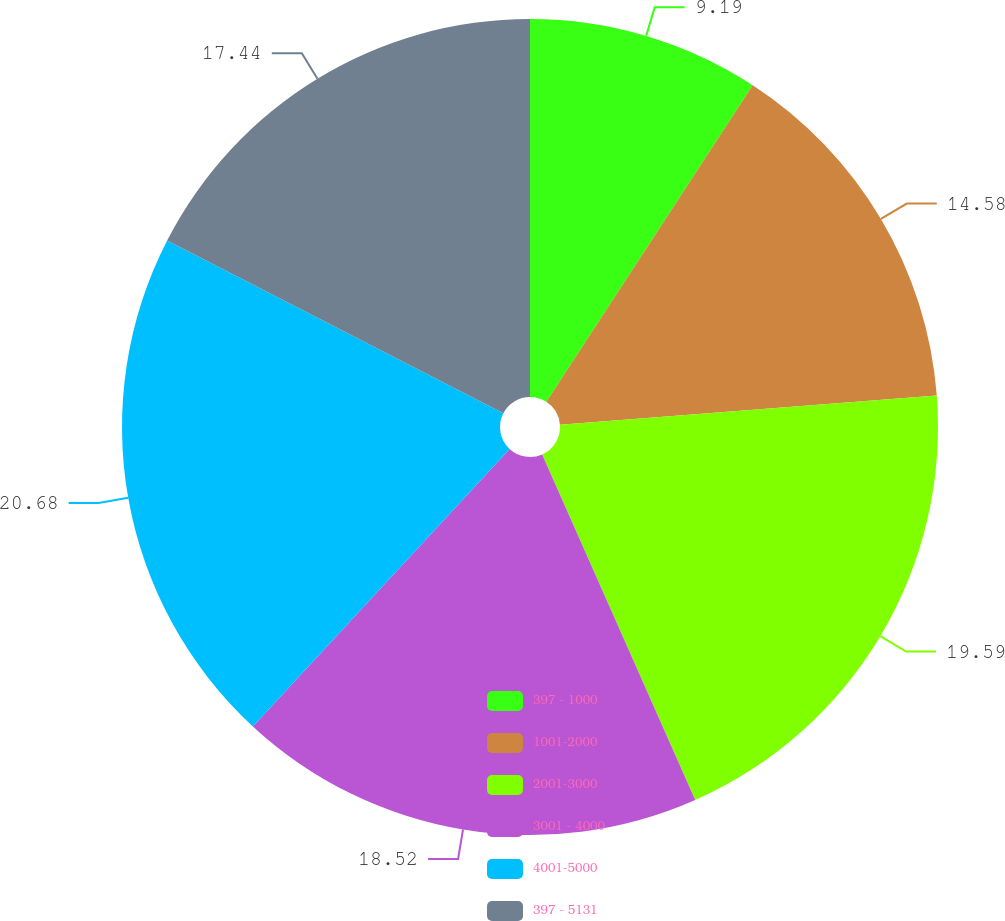Convert chart. <chart><loc_0><loc_0><loc_500><loc_500><pie_chart><fcel>397 - 1000<fcel>1001-2000<fcel>2001-3000<fcel>3001 - 4000<fcel>4001-5000<fcel>397 - 5131<nl><fcel>9.19%<fcel>14.58%<fcel>19.59%<fcel>18.52%<fcel>20.67%<fcel>17.44%<nl></chart> 